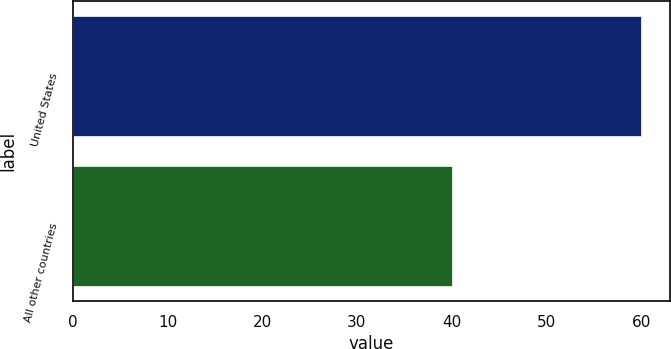<chart> <loc_0><loc_0><loc_500><loc_500><bar_chart><fcel>United States<fcel>All other countries<nl><fcel>60<fcel>40<nl></chart> 